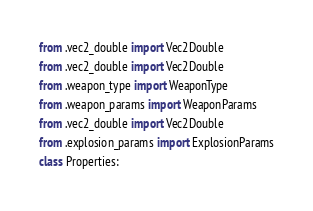<code> <loc_0><loc_0><loc_500><loc_500><_Python_>from .vec2_double import Vec2Double
from .vec2_double import Vec2Double
from .weapon_type import WeaponType
from .weapon_params import WeaponParams
from .vec2_double import Vec2Double
from .explosion_params import ExplosionParams
class Properties:</code> 